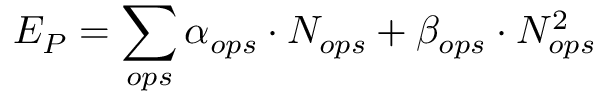<formula> <loc_0><loc_0><loc_500><loc_500>E _ { P } = \sum _ { o p s } \alpha _ { o p s } \cdot N _ { o p s } + \beta _ { o p s } \cdot N _ { o p s } ^ { 2 }</formula> 